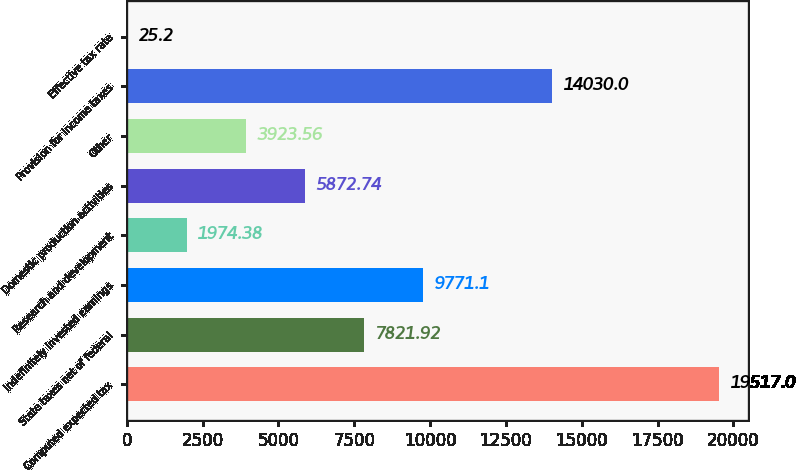<chart> <loc_0><loc_0><loc_500><loc_500><bar_chart><fcel>Computed expected tax<fcel>State taxes net of federal<fcel>Indefinitely invested earnings<fcel>Research and development<fcel>Domestic production activities<fcel>Other<fcel>Provision for income taxes<fcel>Effective tax rate<nl><fcel>19517<fcel>7821.92<fcel>9771.1<fcel>1974.38<fcel>5872.74<fcel>3923.56<fcel>14030<fcel>25.2<nl></chart> 